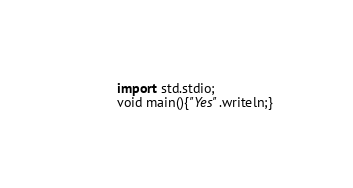Convert code to text. <code><loc_0><loc_0><loc_500><loc_500><_D_>import std.stdio;
void main(){"Yes".writeln;}</code> 